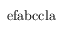Convert formula to latex. <formula><loc_0><loc_0><loc_500><loc_500>e f a b c c l a</formula> 